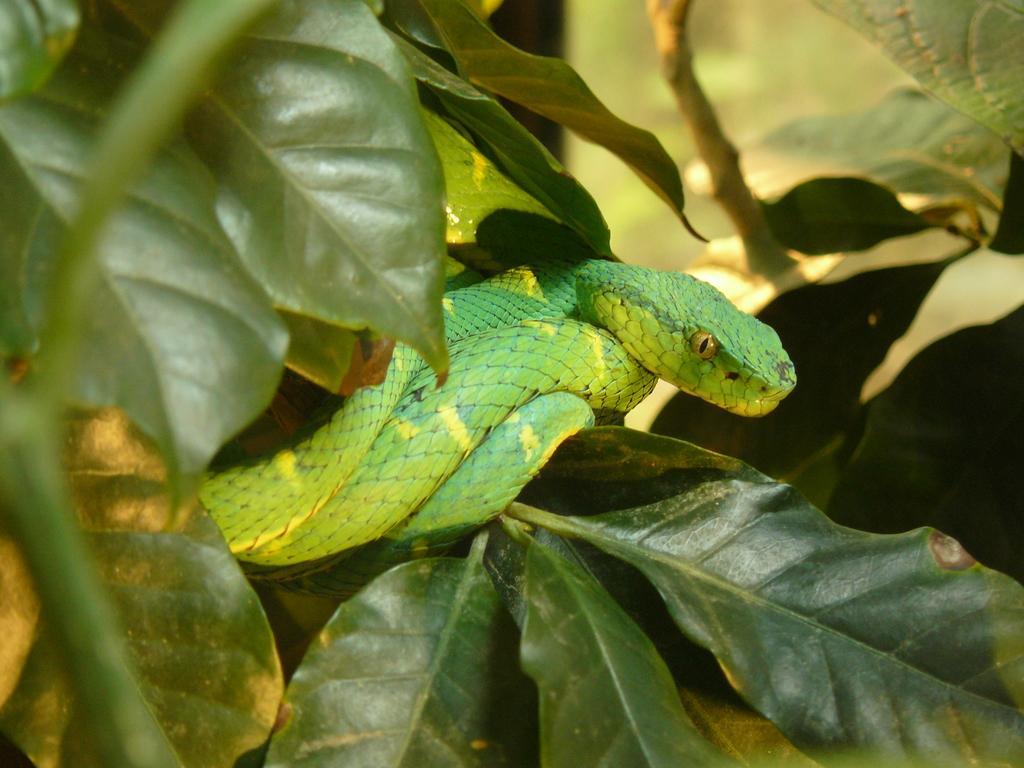In one or two sentences, can you explain what this image depicts? In this image I can see a green color snake on a plant. Here I can see some leaves. 